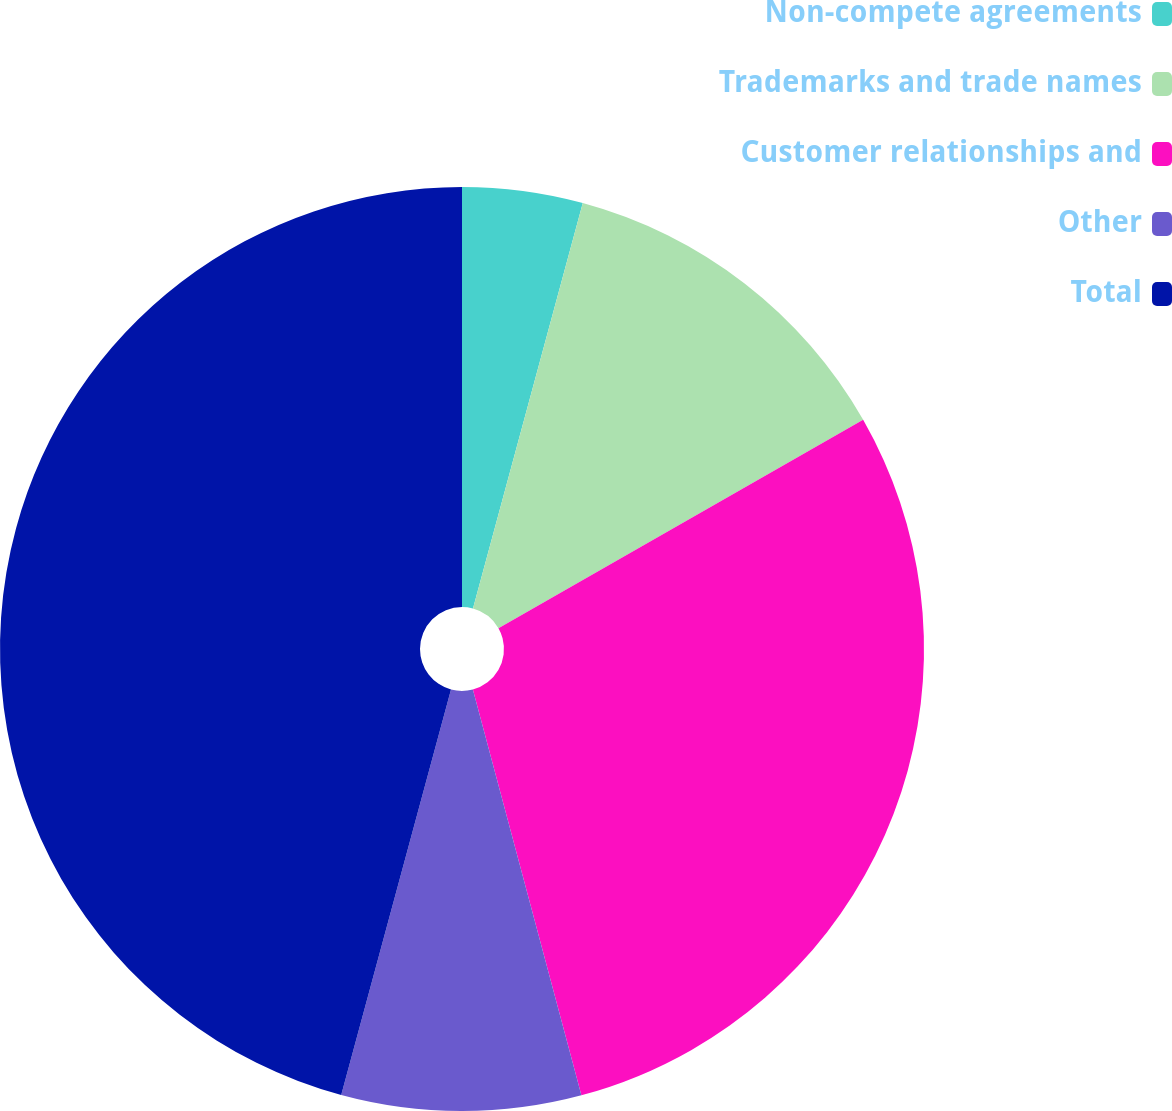<chart> <loc_0><loc_0><loc_500><loc_500><pie_chart><fcel>Non-compete agreements<fcel>Trademarks and trade names<fcel>Customer relationships and<fcel>Other<fcel>Total<nl><fcel>4.21%<fcel>12.53%<fcel>29.1%<fcel>8.37%<fcel>45.79%<nl></chart> 